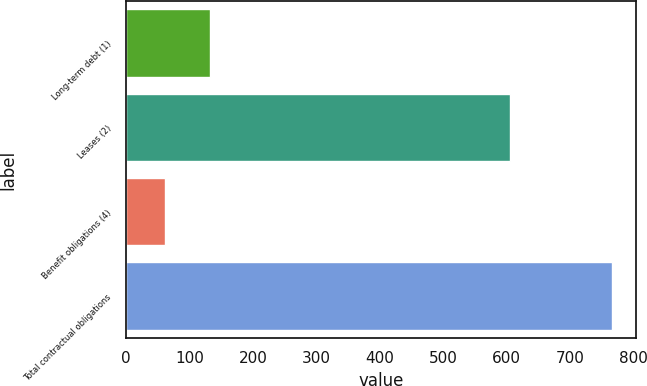Convert chart. <chart><loc_0><loc_0><loc_500><loc_500><bar_chart><fcel>Long-term debt (1)<fcel>Leases (2)<fcel>Benefit obligations (4)<fcel>Total contractual obligations<nl><fcel>132.32<fcel>605.9<fcel>61.9<fcel>766.1<nl></chart> 